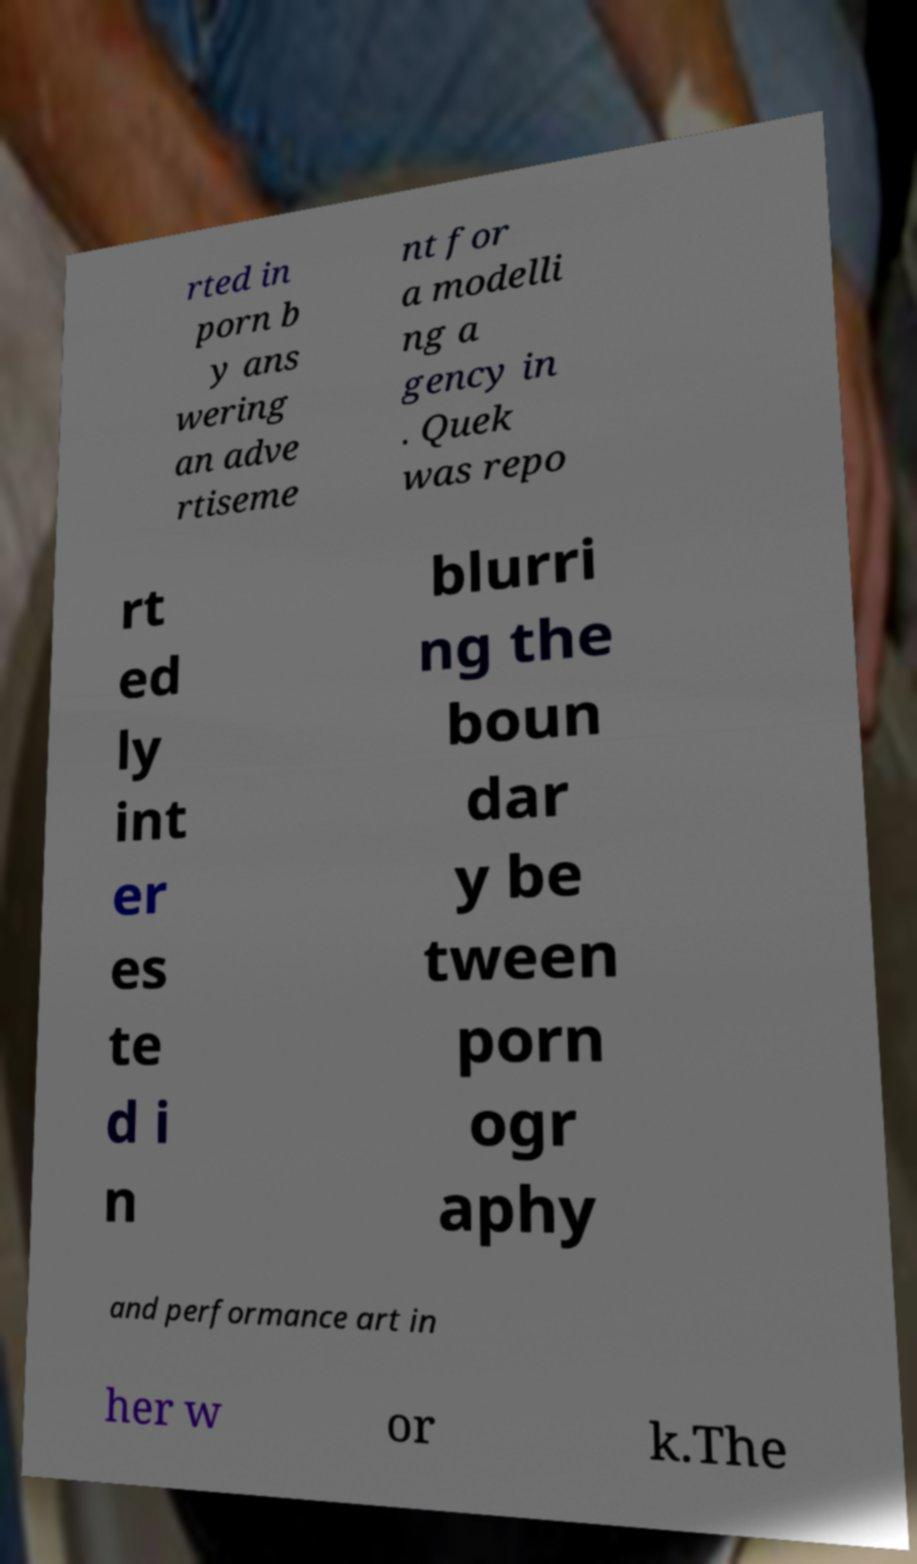There's text embedded in this image that I need extracted. Can you transcribe it verbatim? rted in porn b y ans wering an adve rtiseme nt for a modelli ng a gency in . Quek was repo rt ed ly int er es te d i n blurri ng the boun dar y be tween porn ogr aphy and performance art in her w or k.The 